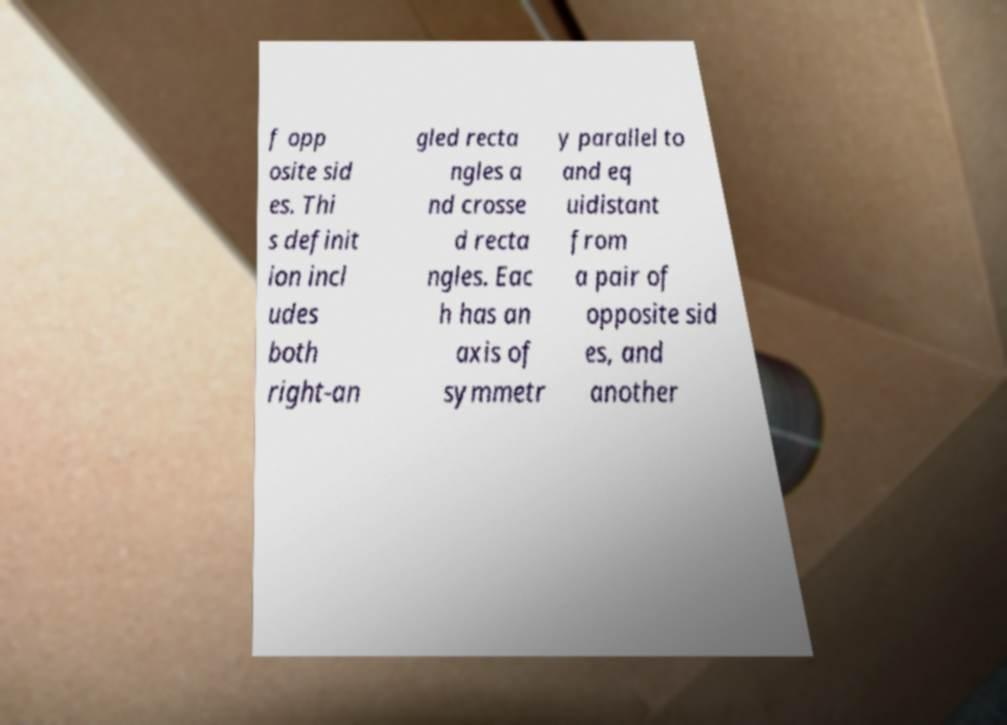Please identify and transcribe the text found in this image. f opp osite sid es. Thi s definit ion incl udes both right-an gled recta ngles a nd crosse d recta ngles. Eac h has an axis of symmetr y parallel to and eq uidistant from a pair of opposite sid es, and another 